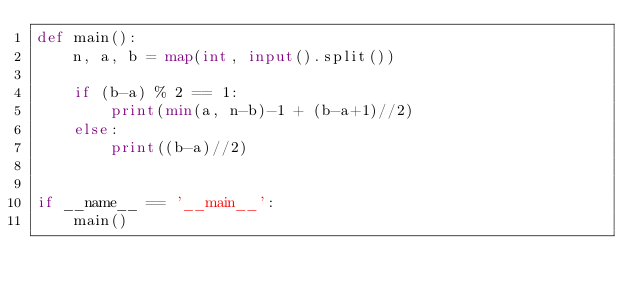<code> <loc_0><loc_0><loc_500><loc_500><_Python_>def main():
    n, a, b = map(int, input().split())

    if (b-a) % 2 == 1:
        print(min(a, n-b)-1 + (b-a+1)//2)
    else:
        print((b-a)//2)


if __name__ == '__main__':
    main()
</code> 